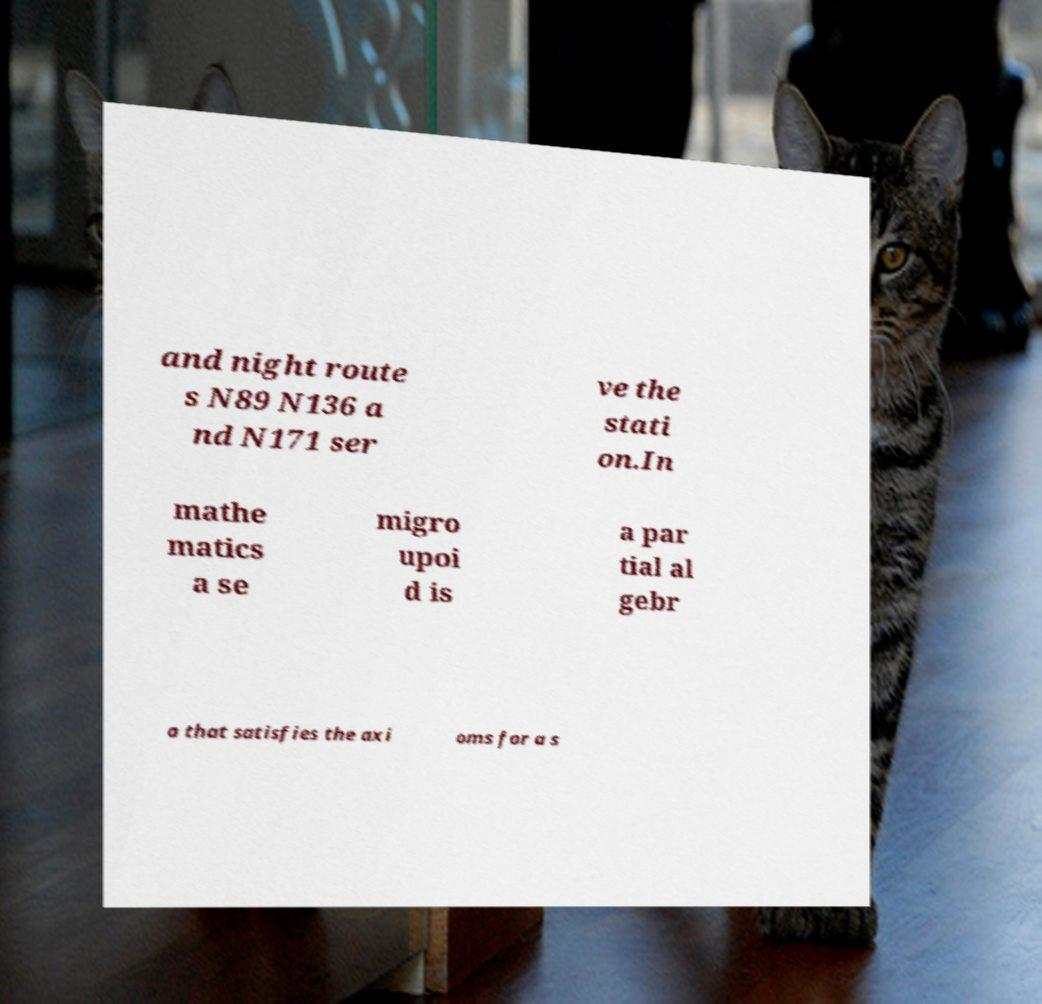There's text embedded in this image that I need extracted. Can you transcribe it verbatim? and night route s N89 N136 a nd N171 ser ve the stati on.In mathe matics a se migro upoi d is a par tial al gebr a that satisfies the axi oms for a s 